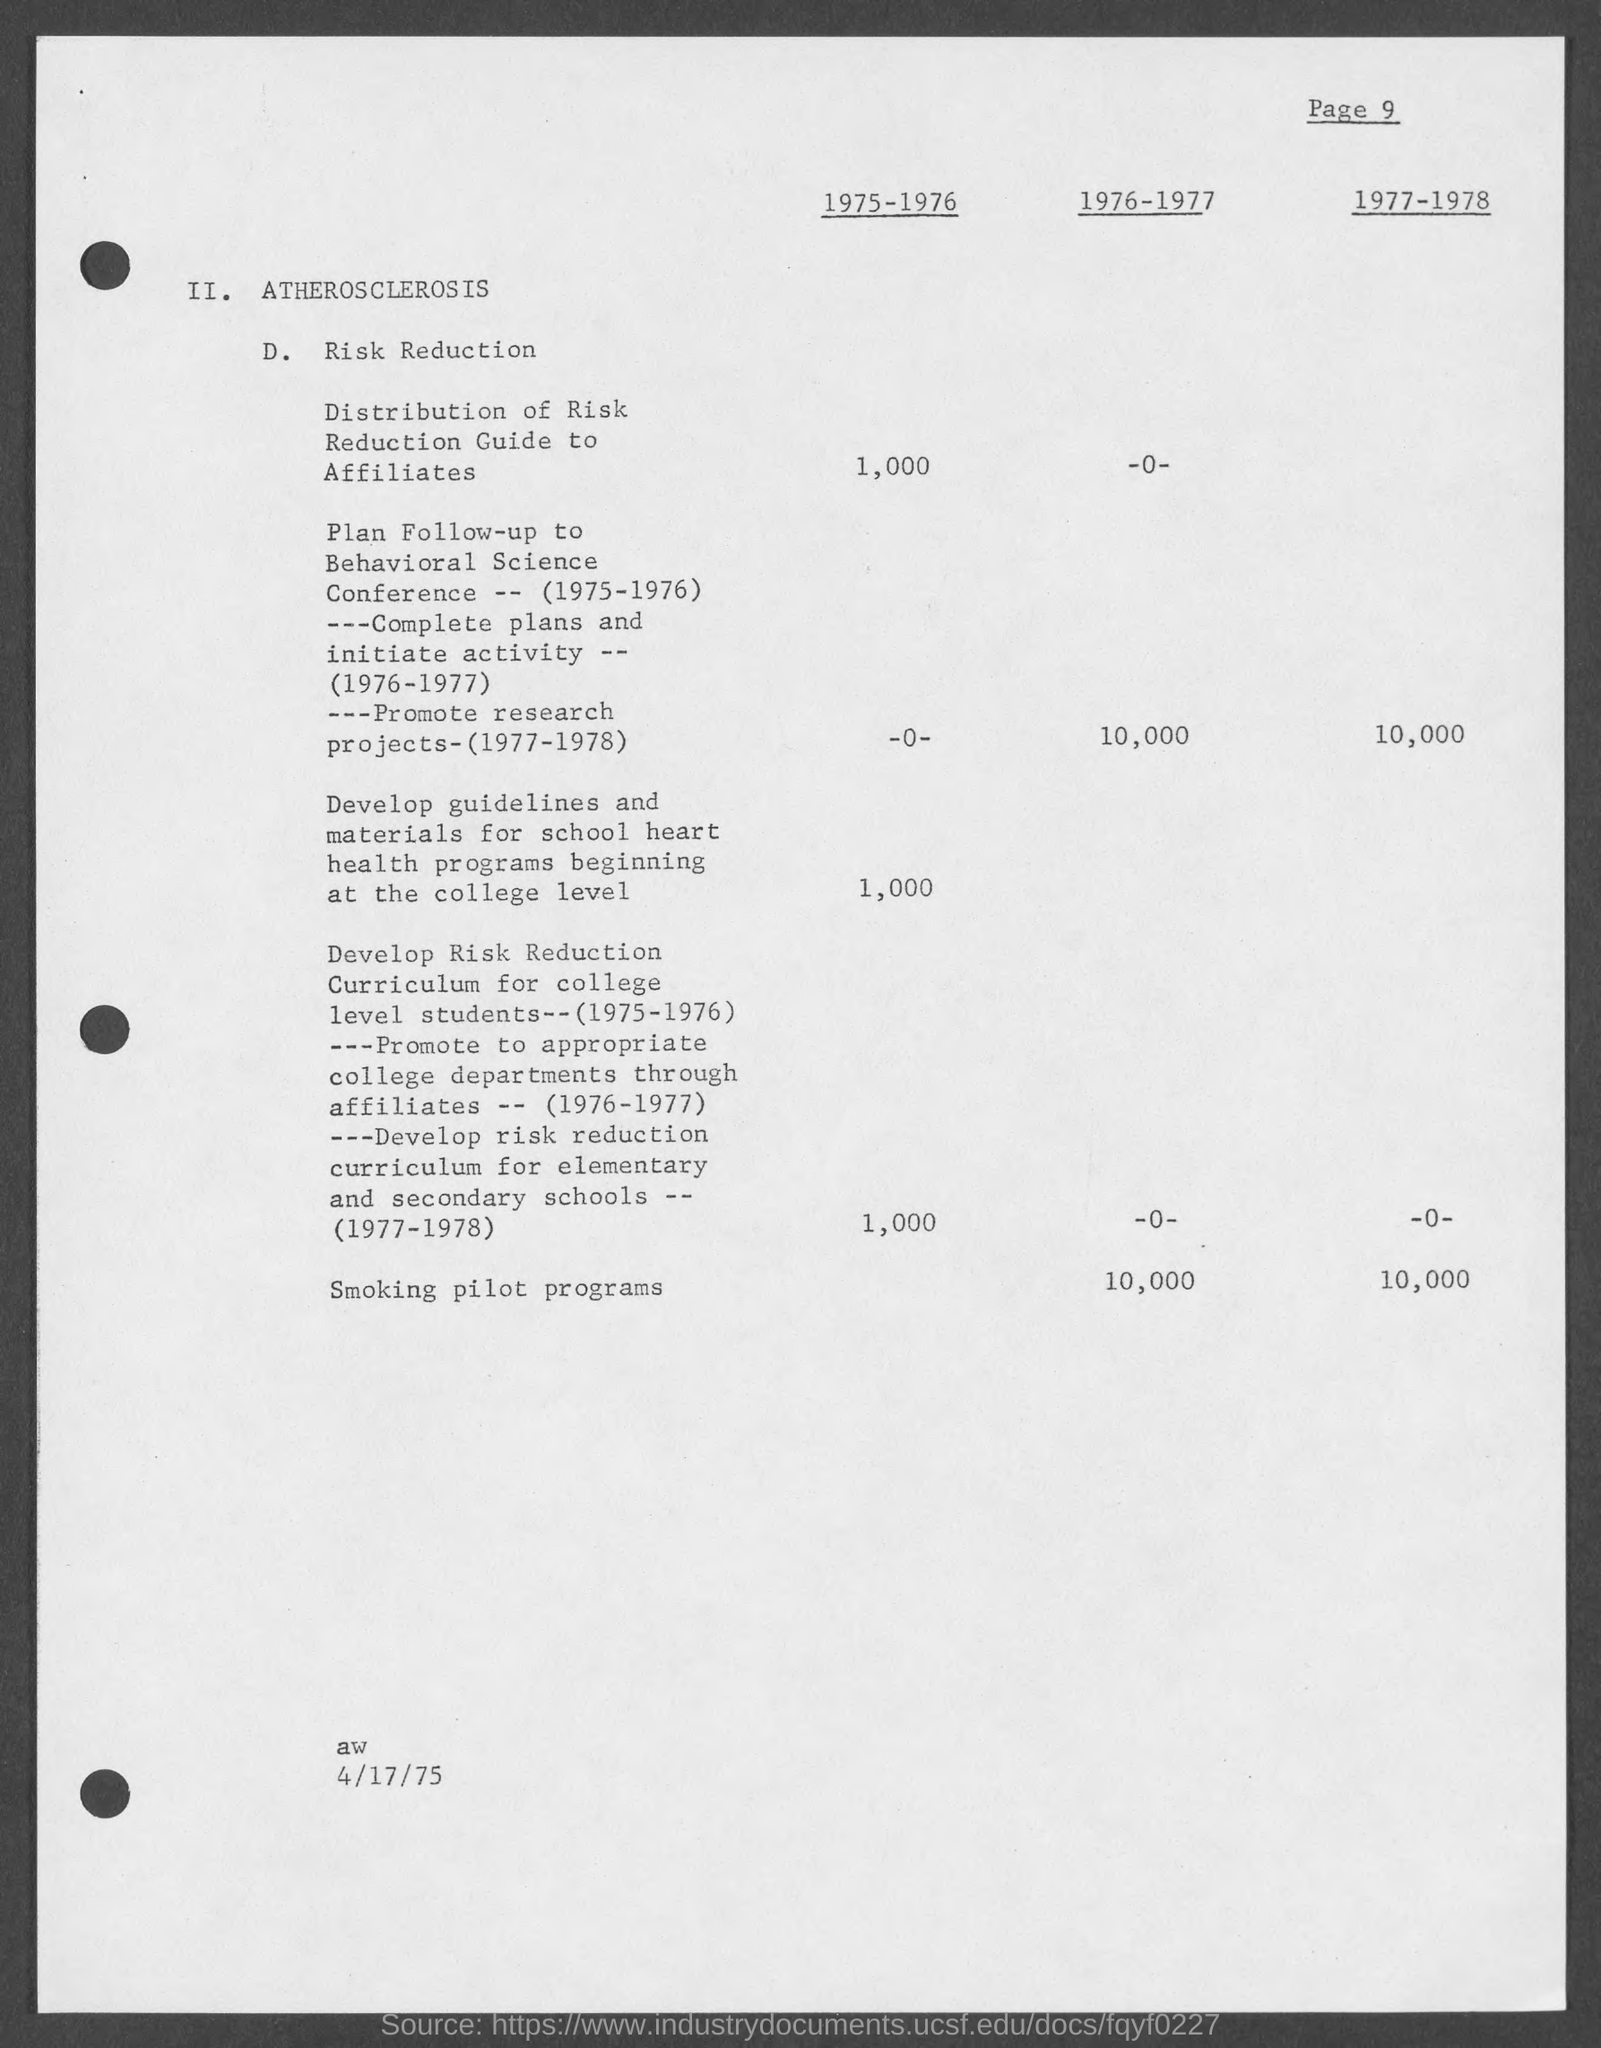Specify some key components in this picture. Approximately 10,000 smoking pilot programs were conducted between 1976 and 1977. In the years 1977-1978, over 10,000 smoking pilot programs were conducted. The date at the bottom of the page is April 17th, 1975. 